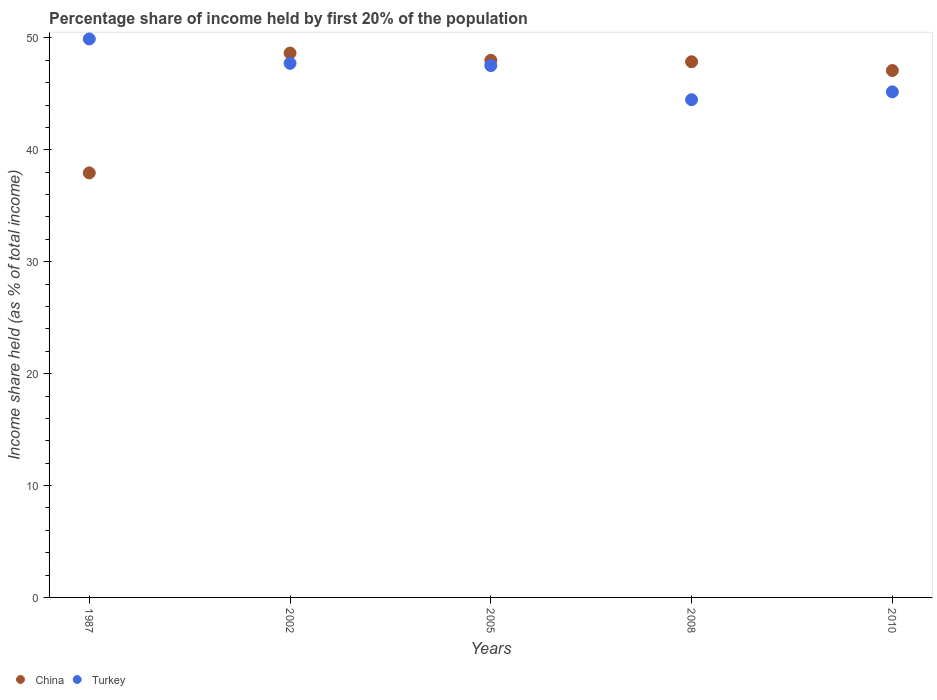What is the share of income held by first 20% of the population in China in 2008?
Provide a short and direct response. 47.87. Across all years, what is the maximum share of income held by first 20% of the population in China?
Provide a succinct answer. 48.65. Across all years, what is the minimum share of income held by first 20% of the population in Turkey?
Make the answer very short. 44.48. In which year was the share of income held by first 20% of the population in Turkey maximum?
Offer a terse response. 1987. In which year was the share of income held by first 20% of the population in China minimum?
Offer a terse response. 1987. What is the total share of income held by first 20% of the population in Turkey in the graph?
Provide a succinct answer. 234.83. What is the difference between the share of income held by first 20% of the population in China in 2005 and that in 2008?
Your answer should be compact. 0.13. What is the difference between the share of income held by first 20% of the population in Turkey in 2002 and the share of income held by first 20% of the population in China in 2010?
Your answer should be very brief. 0.64. What is the average share of income held by first 20% of the population in China per year?
Keep it short and to the point. 45.91. In the year 2005, what is the difference between the share of income held by first 20% of the population in China and share of income held by first 20% of the population in Turkey?
Provide a short and direct response. 0.47. In how many years, is the share of income held by first 20% of the population in China greater than 48 %?
Keep it short and to the point. 1. What is the ratio of the share of income held by first 20% of the population in Turkey in 2005 to that in 2008?
Offer a very short reply. 1.07. Is the share of income held by first 20% of the population in China in 2005 less than that in 2008?
Give a very brief answer. No. What is the difference between the highest and the second highest share of income held by first 20% of the population in China?
Provide a succinct answer. 0.65. What is the difference between the highest and the lowest share of income held by first 20% of the population in Turkey?
Provide a succinct answer. 5.43. In how many years, is the share of income held by first 20% of the population in Turkey greater than the average share of income held by first 20% of the population in Turkey taken over all years?
Your answer should be compact. 3. Is the sum of the share of income held by first 20% of the population in Turkey in 1987 and 2008 greater than the maximum share of income held by first 20% of the population in China across all years?
Ensure brevity in your answer.  Yes. Is the share of income held by first 20% of the population in Turkey strictly less than the share of income held by first 20% of the population in China over the years?
Your response must be concise. No. How many dotlines are there?
Your response must be concise. 2. Does the graph contain grids?
Ensure brevity in your answer.  No. What is the title of the graph?
Provide a short and direct response. Percentage share of income held by first 20% of the population. What is the label or title of the Y-axis?
Your answer should be very brief. Income share held (as % of total income). What is the Income share held (as % of total income) of China in 1987?
Keep it short and to the point. 37.94. What is the Income share held (as % of total income) in Turkey in 1987?
Make the answer very short. 49.91. What is the Income share held (as % of total income) of China in 2002?
Provide a succinct answer. 48.65. What is the Income share held (as % of total income) in Turkey in 2002?
Make the answer very short. 47.73. What is the Income share held (as % of total income) of China in 2005?
Give a very brief answer. 48. What is the Income share held (as % of total income) in Turkey in 2005?
Your response must be concise. 47.53. What is the Income share held (as % of total income) in China in 2008?
Offer a very short reply. 47.87. What is the Income share held (as % of total income) in Turkey in 2008?
Provide a succinct answer. 44.48. What is the Income share held (as % of total income) of China in 2010?
Offer a terse response. 47.09. What is the Income share held (as % of total income) in Turkey in 2010?
Your answer should be very brief. 45.18. Across all years, what is the maximum Income share held (as % of total income) in China?
Make the answer very short. 48.65. Across all years, what is the maximum Income share held (as % of total income) of Turkey?
Keep it short and to the point. 49.91. Across all years, what is the minimum Income share held (as % of total income) of China?
Your answer should be compact. 37.94. Across all years, what is the minimum Income share held (as % of total income) in Turkey?
Your answer should be compact. 44.48. What is the total Income share held (as % of total income) of China in the graph?
Your answer should be compact. 229.55. What is the total Income share held (as % of total income) in Turkey in the graph?
Offer a terse response. 234.83. What is the difference between the Income share held (as % of total income) in China in 1987 and that in 2002?
Offer a very short reply. -10.71. What is the difference between the Income share held (as % of total income) of Turkey in 1987 and that in 2002?
Provide a succinct answer. 2.18. What is the difference between the Income share held (as % of total income) of China in 1987 and that in 2005?
Provide a short and direct response. -10.06. What is the difference between the Income share held (as % of total income) in Turkey in 1987 and that in 2005?
Your answer should be compact. 2.38. What is the difference between the Income share held (as % of total income) of China in 1987 and that in 2008?
Make the answer very short. -9.93. What is the difference between the Income share held (as % of total income) of Turkey in 1987 and that in 2008?
Make the answer very short. 5.43. What is the difference between the Income share held (as % of total income) of China in 1987 and that in 2010?
Make the answer very short. -9.15. What is the difference between the Income share held (as % of total income) of Turkey in 1987 and that in 2010?
Ensure brevity in your answer.  4.73. What is the difference between the Income share held (as % of total income) in China in 2002 and that in 2005?
Provide a short and direct response. 0.65. What is the difference between the Income share held (as % of total income) of Turkey in 2002 and that in 2005?
Offer a very short reply. 0.2. What is the difference between the Income share held (as % of total income) in China in 2002 and that in 2008?
Your response must be concise. 0.78. What is the difference between the Income share held (as % of total income) of Turkey in 2002 and that in 2008?
Your response must be concise. 3.25. What is the difference between the Income share held (as % of total income) in China in 2002 and that in 2010?
Offer a very short reply. 1.56. What is the difference between the Income share held (as % of total income) of Turkey in 2002 and that in 2010?
Your answer should be very brief. 2.55. What is the difference between the Income share held (as % of total income) in China in 2005 and that in 2008?
Your response must be concise. 0.13. What is the difference between the Income share held (as % of total income) of Turkey in 2005 and that in 2008?
Provide a short and direct response. 3.05. What is the difference between the Income share held (as % of total income) of China in 2005 and that in 2010?
Offer a terse response. 0.91. What is the difference between the Income share held (as % of total income) in Turkey in 2005 and that in 2010?
Your answer should be very brief. 2.35. What is the difference between the Income share held (as % of total income) of China in 2008 and that in 2010?
Ensure brevity in your answer.  0.78. What is the difference between the Income share held (as % of total income) in Turkey in 2008 and that in 2010?
Your answer should be compact. -0.7. What is the difference between the Income share held (as % of total income) in China in 1987 and the Income share held (as % of total income) in Turkey in 2002?
Your response must be concise. -9.79. What is the difference between the Income share held (as % of total income) of China in 1987 and the Income share held (as % of total income) of Turkey in 2005?
Make the answer very short. -9.59. What is the difference between the Income share held (as % of total income) in China in 1987 and the Income share held (as % of total income) in Turkey in 2008?
Provide a succinct answer. -6.54. What is the difference between the Income share held (as % of total income) of China in 1987 and the Income share held (as % of total income) of Turkey in 2010?
Your answer should be compact. -7.24. What is the difference between the Income share held (as % of total income) in China in 2002 and the Income share held (as % of total income) in Turkey in 2005?
Your response must be concise. 1.12. What is the difference between the Income share held (as % of total income) of China in 2002 and the Income share held (as % of total income) of Turkey in 2008?
Keep it short and to the point. 4.17. What is the difference between the Income share held (as % of total income) in China in 2002 and the Income share held (as % of total income) in Turkey in 2010?
Give a very brief answer. 3.47. What is the difference between the Income share held (as % of total income) in China in 2005 and the Income share held (as % of total income) in Turkey in 2008?
Offer a very short reply. 3.52. What is the difference between the Income share held (as % of total income) of China in 2005 and the Income share held (as % of total income) of Turkey in 2010?
Make the answer very short. 2.82. What is the difference between the Income share held (as % of total income) in China in 2008 and the Income share held (as % of total income) in Turkey in 2010?
Ensure brevity in your answer.  2.69. What is the average Income share held (as % of total income) in China per year?
Provide a short and direct response. 45.91. What is the average Income share held (as % of total income) in Turkey per year?
Make the answer very short. 46.97. In the year 1987, what is the difference between the Income share held (as % of total income) in China and Income share held (as % of total income) in Turkey?
Keep it short and to the point. -11.97. In the year 2005, what is the difference between the Income share held (as % of total income) in China and Income share held (as % of total income) in Turkey?
Keep it short and to the point. 0.47. In the year 2008, what is the difference between the Income share held (as % of total income) in China and Income share held (as % of total income) in Turkey?
Offer a very short reply. 3.39. In the year 2010, what is the difference between the Income share held (as % of total income) in China and Income share held (as % of total income) in Turkey?
Your answer should be compact. 1.91. What is the ratio of the Income share held (as % of total income) in China in 1987 to that in 2002?
Provide a succinct answer. 0.78. What is the ratio of the Income share held (as % of total income) in Turkey in 1987 to that in 2002?
Provide a succinct answer. 1.05. What is the ratio of the Income share held (as % of total income) of China in 1987 to that in 2005?
Make the answer very short. 0.79. What is the ratio of the Income share held (as % of total income) of Turkey in 1987 to that in 2005?
Offer a terse response. 1.05. What is the ratio of the Income share held (as % of total income) in China in 1987 to that in 2008?
Give a very brief answer. 0.79. What is the ratio of the Income share held (as % of total income) of Turkey in 1987 to that in 2008?
Provide a succinct answer. 1.12. What is the ratio of the Income share held (as % of total income) of China in 1987 to that in 2010?
Offer a terse response. 0.81. What is the ratio of the Income share held (as % of total income) in Turkey in 1987 to that in 2010?
Ensure brevity in your answer.  1.1. What is the ratio of the Income share held (as % of total income) of China in 2002 to that in 2005?
Provide a short and direct response. 1.01. What is the ratio of the Income share held (as % of total income) of Turkey in 2002 to that in 2005?
Provide a short and direct response. 1. What is the ratio of the Income share held (as % of total income) of China in 2002 to that in 2008?
Provide a short and direct response. 1.02. What is the ratio of the Income share held (as % of total income) in Turkey in 2002 to that in 2008?
Give a very brief answer. 1.07. What is the ratio of the Income share held (as % of total income) of China in 2002 to that in 2010?
Offer a very short reply. 1.03. What is the ratio of the Income share held (as % of total income) in Turkey in 2002 to that in 2010?
Give a very brief answer. 1.06. What is the ratio of the Income share held (as % of total income) in China in 2005 to that in 2008?
Keep it short and to the point. 1. What is the ratio of the Income share held (as % of total income) of Turkey in 2005 to that in 2008?
Provide a short and direct response. 1.07. What is the ratio of the Income share held (as % of total income) of China in 2005 to that in 2010?
Offer a very short reply. 1.02. What is the ratio of the Income share held (as % of total income) of Turkey in 2005 to that in 2010?
Give a very brief answer. 1.05. What is the ratio of the Income share held (as % of total income) of China in 2008 to that in 2010?
Provide a succinct answer. 1.02. What is the ratio of the Income share held (as % of total income) in Turkey in 2008 to that in 2010?
Make the answer very short. 0.98. What is the difference between the highest and the second highest Income share held (as % of total income) of China?
Offer a very short reply. 0.65. What is the difference between the highest and the second highest Income share held (as % of total income) of Turkey?
Provide a succinct answer. 2.18. What is the difference between the highest and the lowest Income share held (as % of total income) in China?
Provide a succinct answer. 10.71. What is the difference between the highest and the lowest Income share held (as % of total income) in Turkey?
Your answer should be very brief. 5.43. 